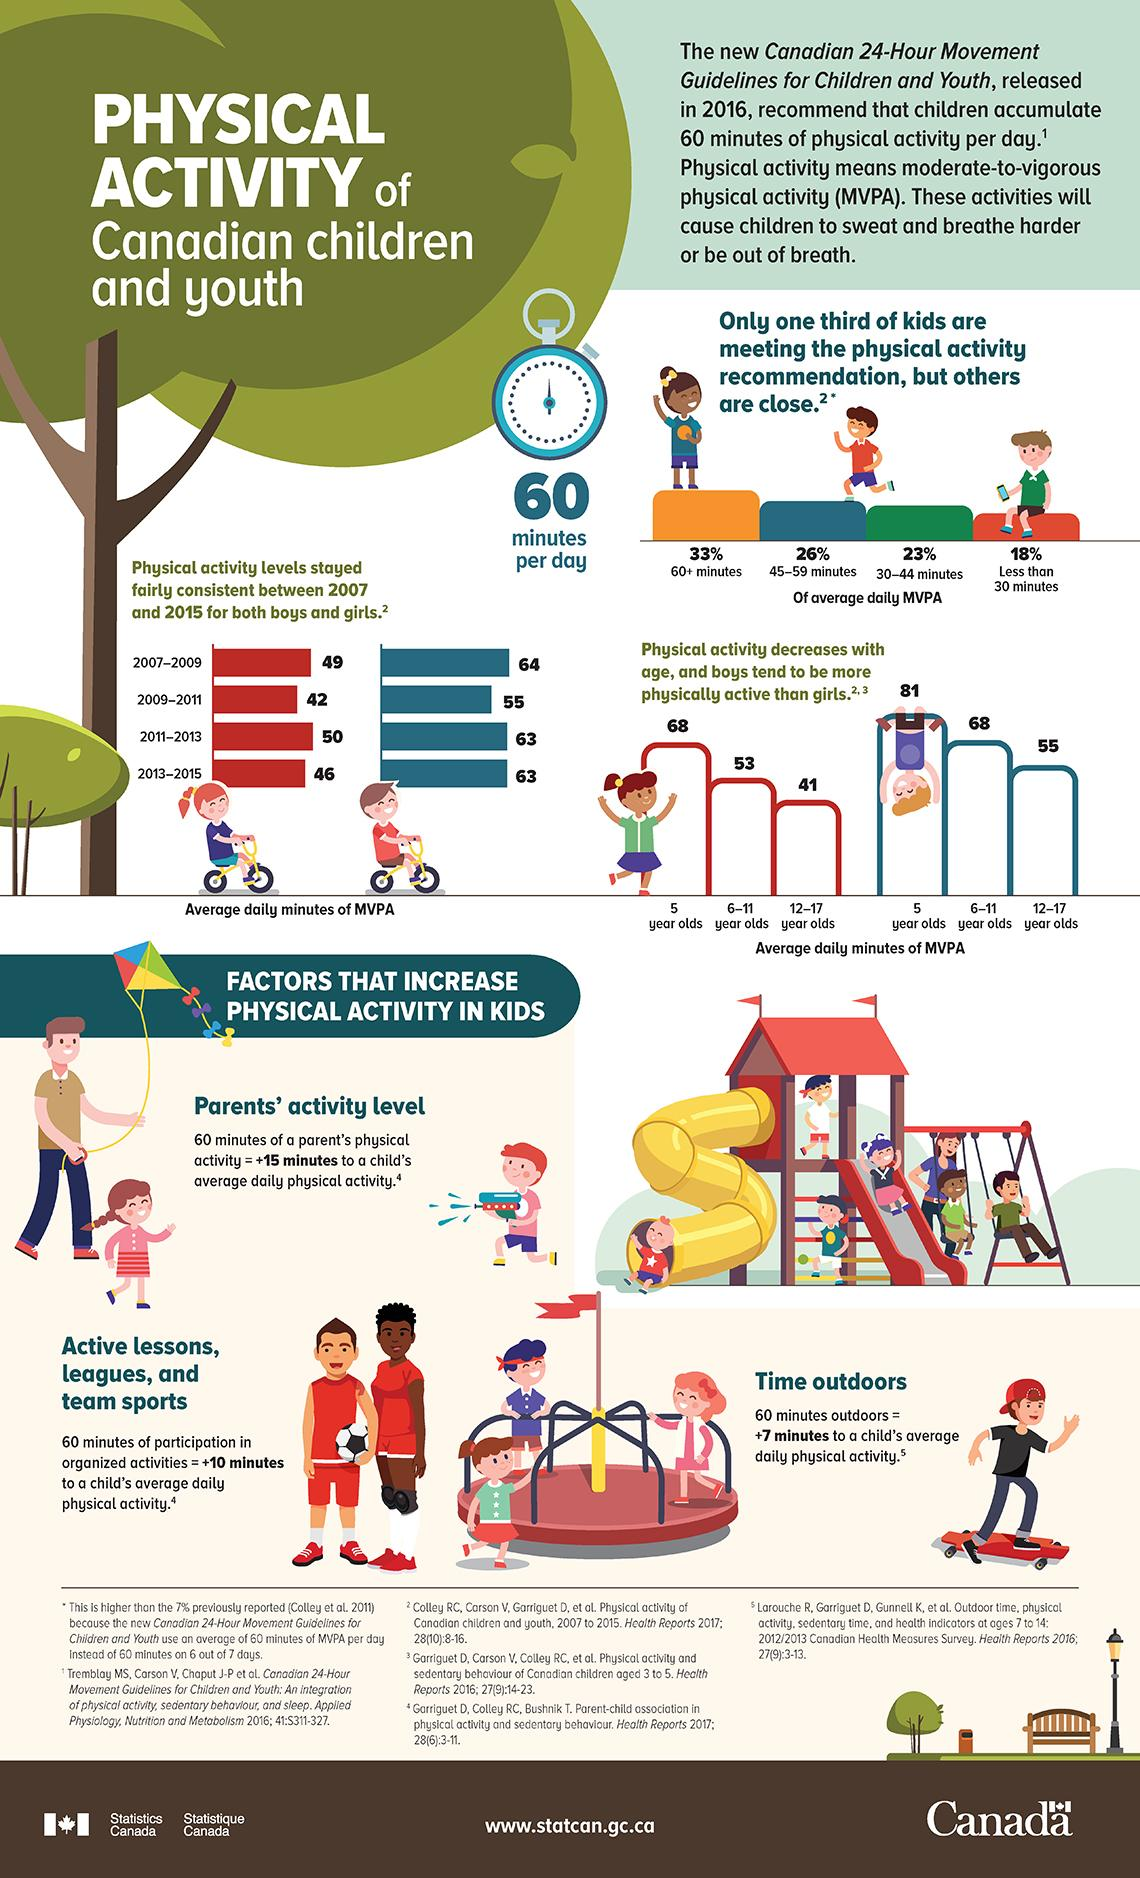Mention a couple of crucial points in this snapshot. It is estimated that 6-11 year old boys have significantly more average daily minutes of MVPA than girls of the same age group. The study found that 5-year-old boys have more average daily minutes of moderate-to-vigorous physical activity (MVPA) compared to girls of the same age. The study found that 12-17 year old boys had significantly more average daily minutes of MVPA compared to girls of the same age group. In 2007-2009, the average daily minutes of MVPA among boys and girls were significantly different, with boys averaging more minutes per day than girls. In 2011-2013, the average daily minutes of moderate-vigorous physical activity (MVPA) among boys and girls differed significantly, with boys averaging more MVPA per day. 